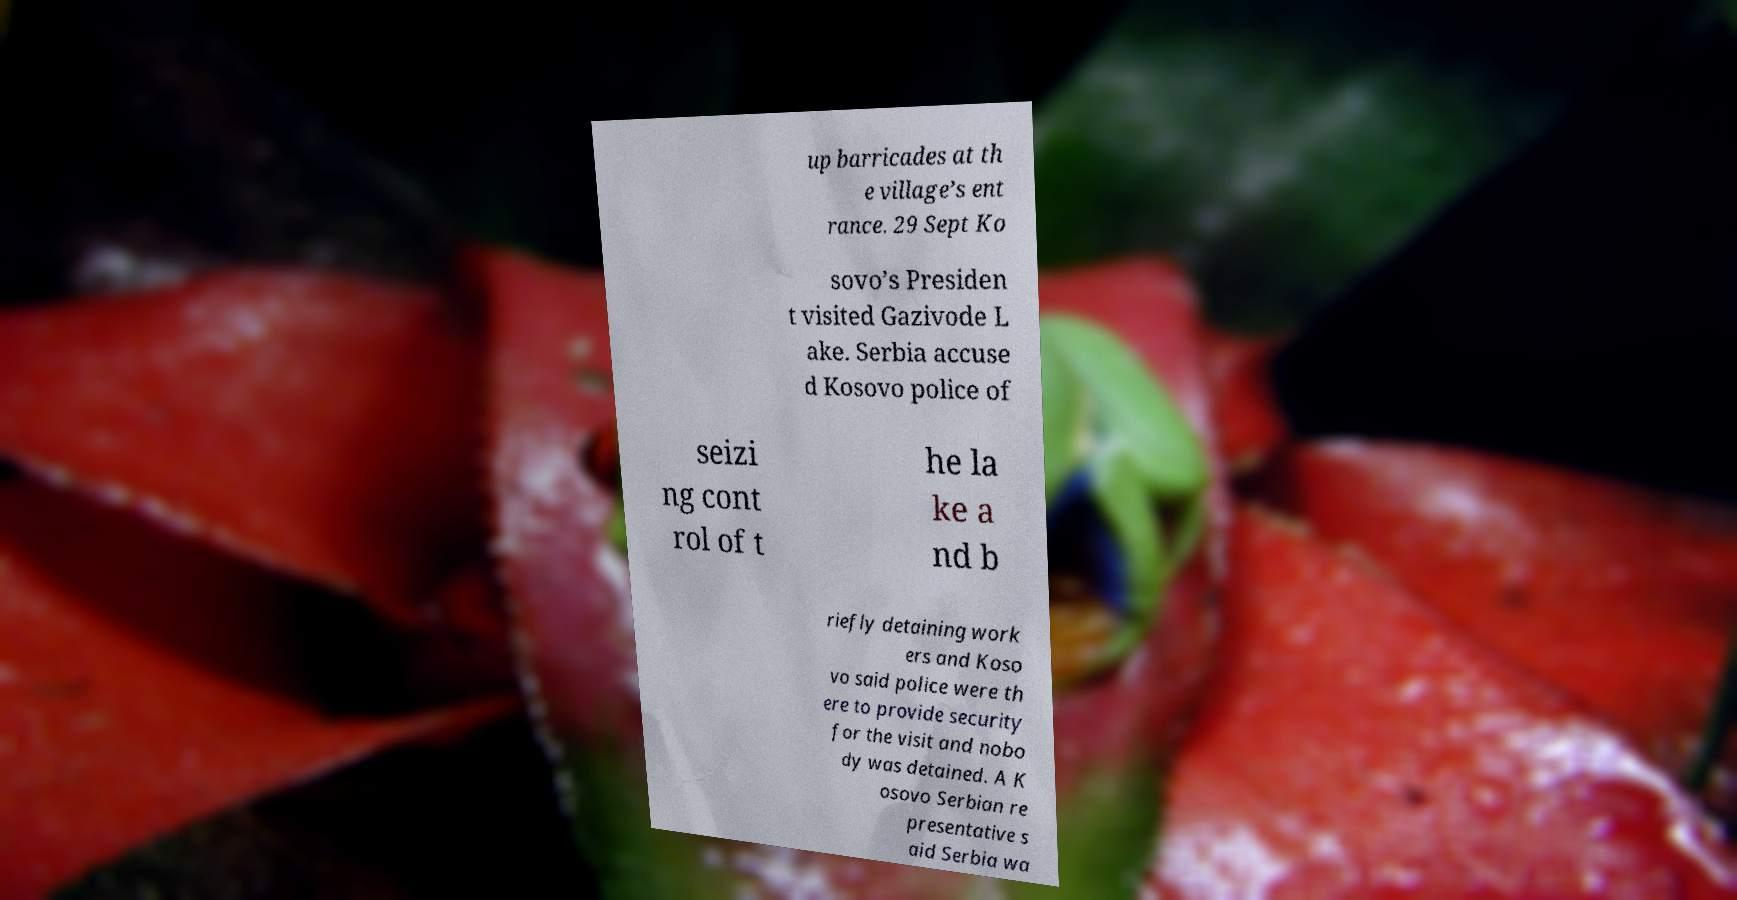What messages or text are displayed in this image? I need them in a readable, typed format. up barricades at th e village’s ent rance. 29 Sept Ko sovo’s Presiden t visited Gazivode L ake. Serbia accuse d Kosovo police of seizi ng cont rol of t he la ke a nd b riefly detaining work ers and Koso vo said police were th ere to provide security for the visit and nobo dy was detained. A K osovo Serbian re presentative s aid Serbia wa 